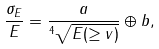Convert formula to latex. <formula><loc_0><loc_0><loc_500><loc_500>\frac { \sigma _ { E } } { E } = \frac { a } { ^ { 4 } \sqrt { E ( \geq v ) } } \oplus b ,</formula> 